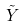<formula> <loc_0><loc_0><loc_500><loc_500>\tilde { Y }</formula> 